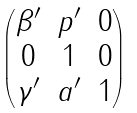<formula> <loc_0><loc_0><loc_500><loc_500>\begin{pmatrix} \beta ^ { \prime } & p ^ { \prime } & 0 \\ 0 & 1 & 0 \\ \gamma ^ { \prime } & a ^ { \prime } & 1 \end{pmatrix}</formula> 